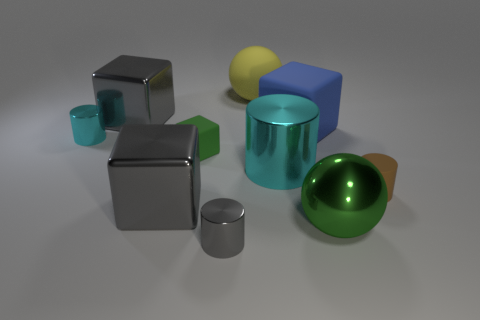Subtract 1 cubes. How many cubes are left? 3 Subtract all cylinders. How many objects are left? 6 Add 10 green cylinders. How many green cylinders exist? 10 Subtract 1 green blocks. How many objects are left? 9 Subtract all large spheres. Subtract all tiny cyan cylinders. How many objects are left? 7 Add 3 large blue objects. How many large blue objects are left? 4 